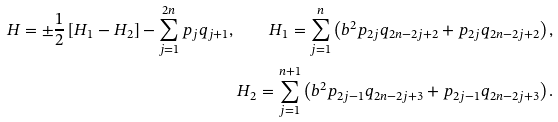Convert formula to latex. <formula><loc_0><loc_0><loc_500><loc_500>H = \pm \frac { 1 } { 2 } \left [ H _ { 1 } - H _ { 2 } \right ] - \sum _ { j = 1 } ^ { 2 n } p _ { j } q _ { j + 1 } , \quad H _ { 1 } = \sum _ { j = 1 } ^ { n } \left ( b ^ { 2 } p _ { 2 j } q _ { 2 n - 2 j + 2 } + p _ { 2 j } q _ { 2 n - 2 j + 2 } \right ) , \\ H _ { 2 } = \sum _ { j = 1 } ^ { n + 1 } \left ( b ^ { 2 } p _ { 2 j - 1 } q _ { 2 n - 2 j + 3 } + p _ { 2 j - 1 } q _ { 2 n - 2 j + 3 } \right ) .</formula> 